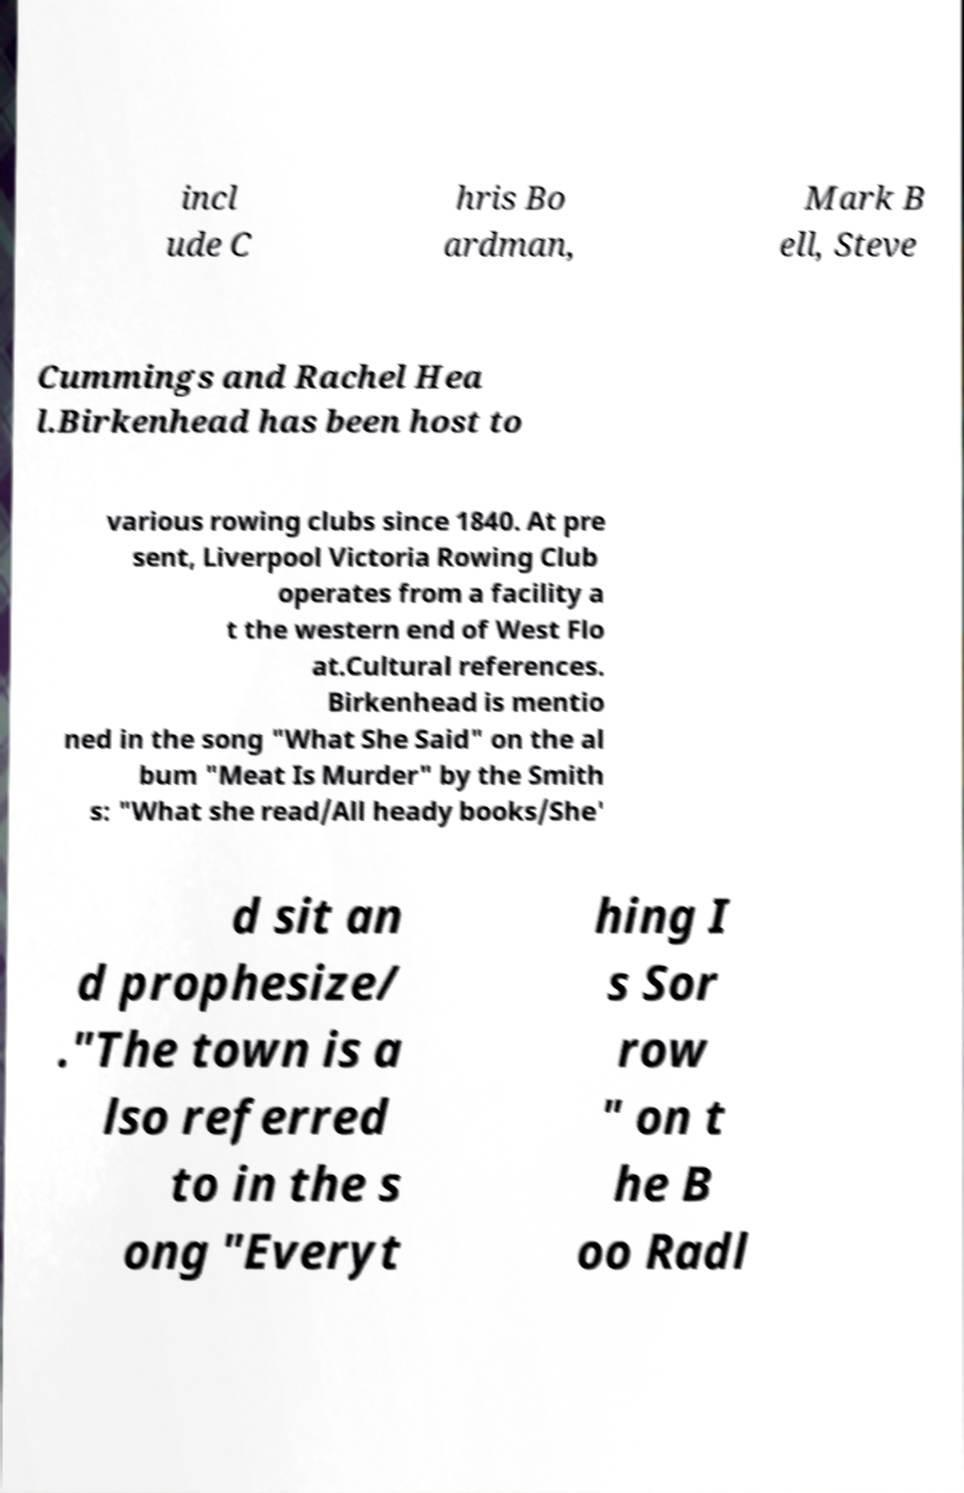For documentation purposes, I need the text within this image transcribed. Could you provide that? incl ude C hris Bo ardman, Mark B ell, Steve Cummings and Rachel Hea l.Birkenhead has been host to various rowing clubs since 1840. At pre sent, Liverpool Victoria Rowing Club operates from a facility a t the western end of West Flo at.Cultural references. Birkenhead is mentio ned in the song "What She Said" on the al bum "Meat Is Murder" by the Smith s: "What she read/All heady books/She' d sit an d prophesize/ ."The town is a lso referred to in the s ong "Everyt hing I s Sor row " on t he B oo Radl 